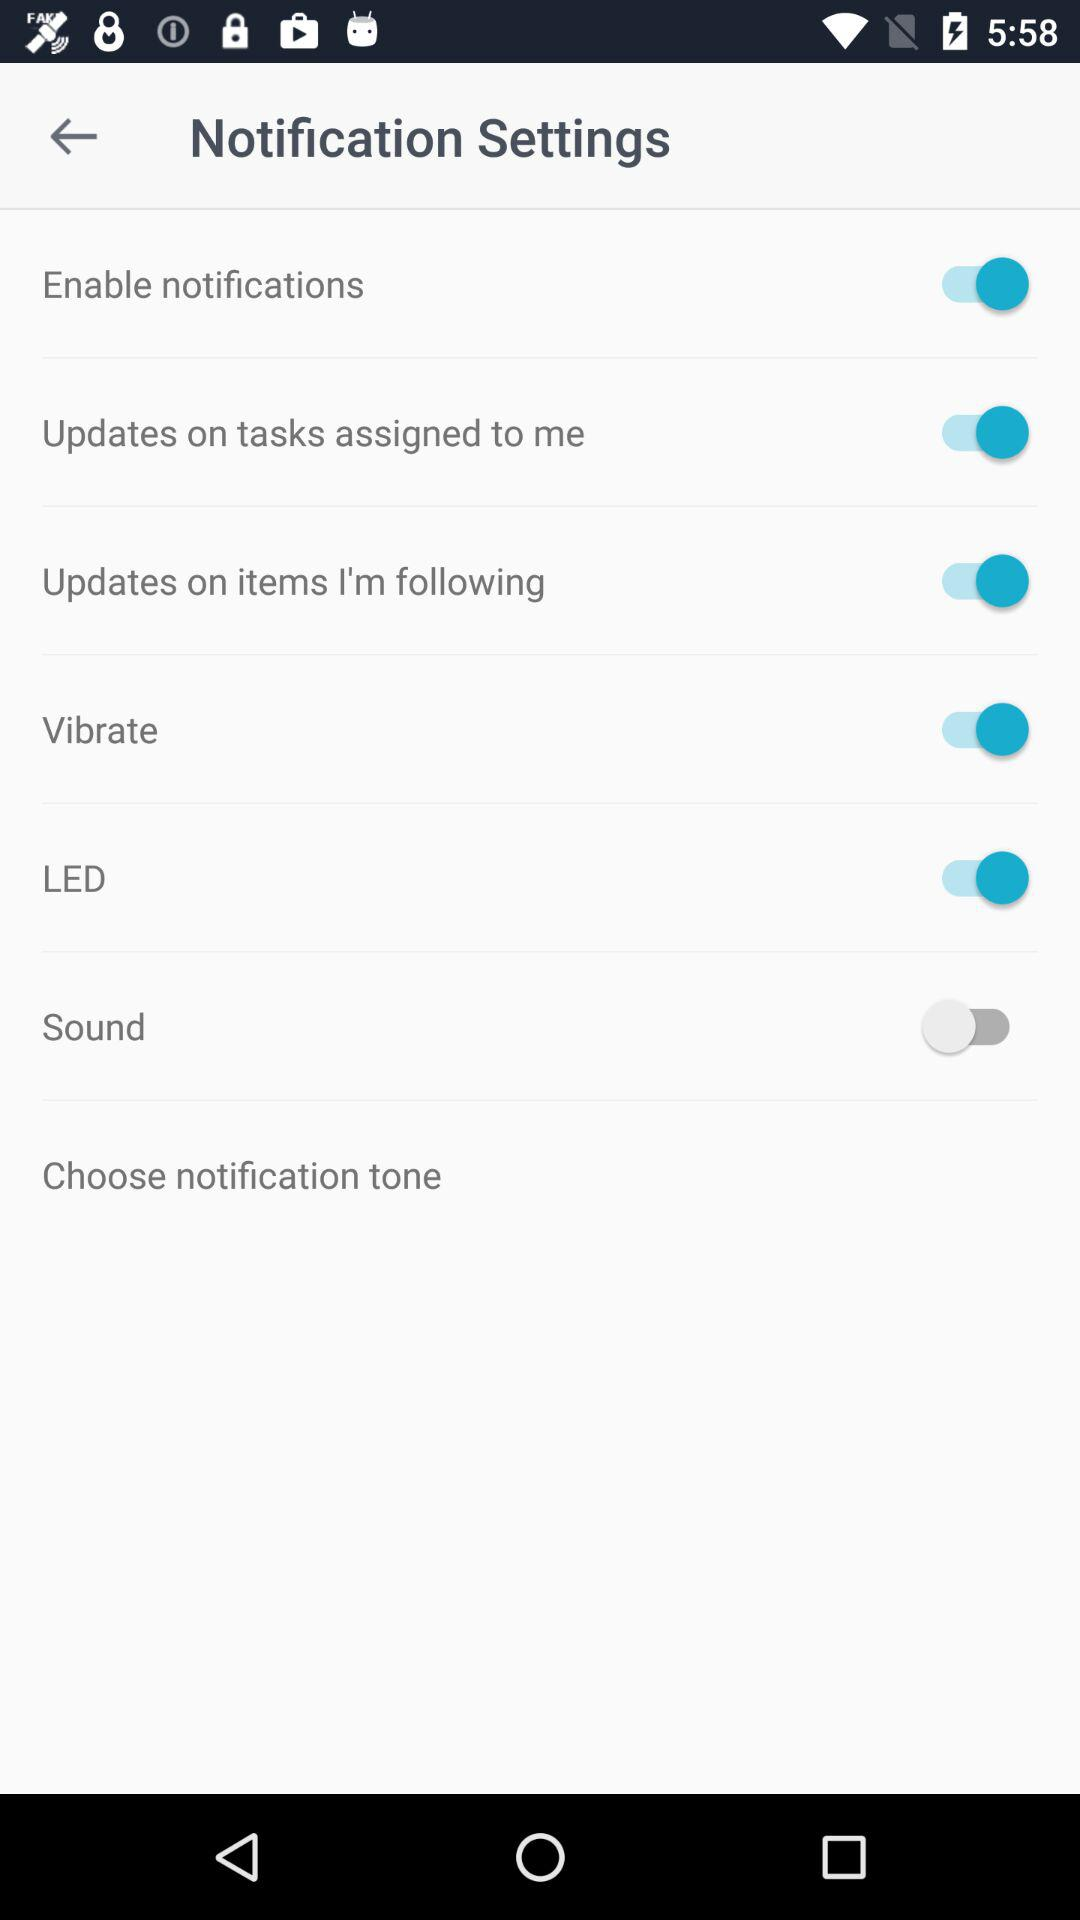What is the status of "Sound"? The status of "Sound" is "off". 